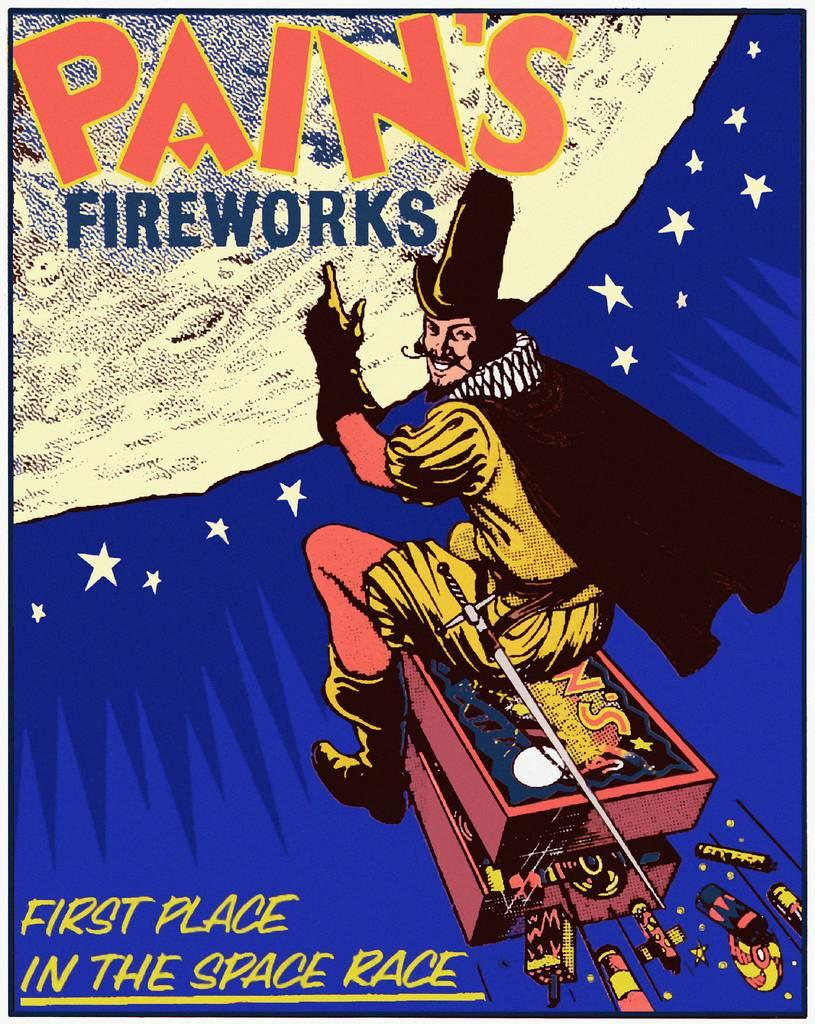Provide a one-sentence caption for the provided image. An advertisement for Pain's Fireworks that shows a man riding towards the moon. 